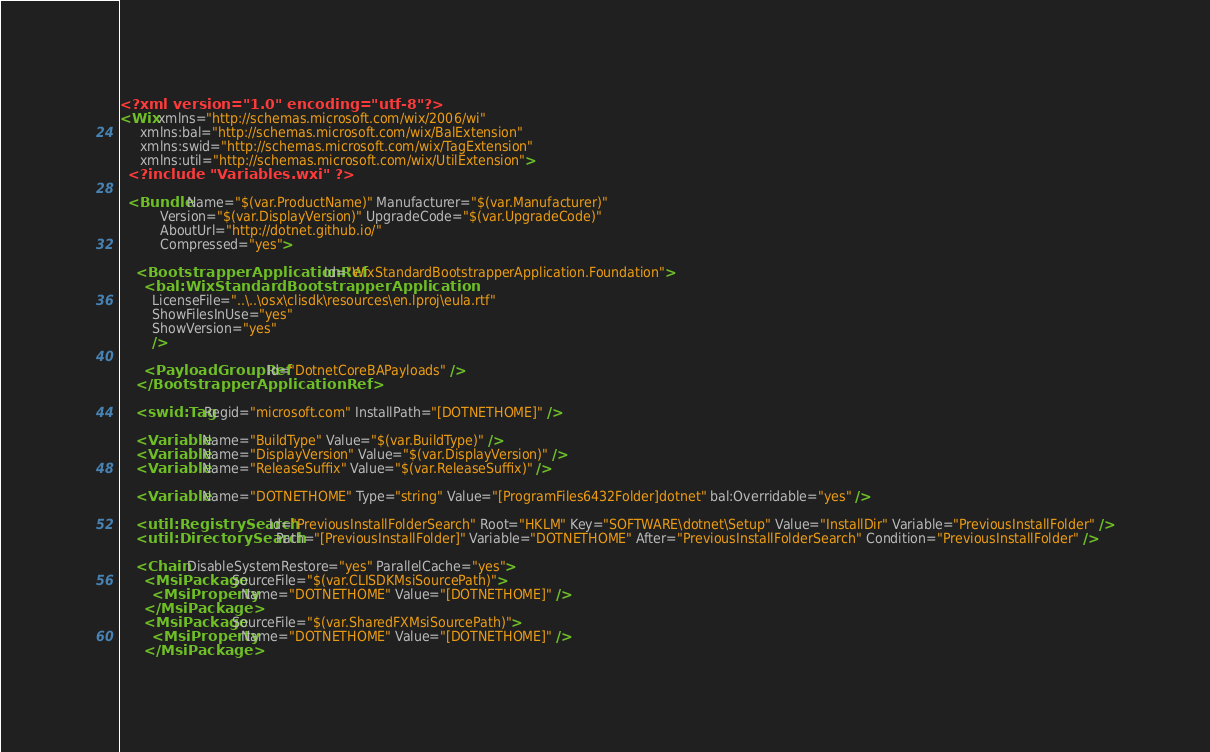Convert code to text. <code><loc_0><loc_0><loc_500><loc_500><_XML_><?xml version="1.0" encoding="utf-8"?>
<Wix xmlns="http://schemas.microsoft.com/wix/2006/wi"
     xmlns:bal="http://schemas.microsoft.com/wix/BalExtension"
     xmlns:swid="http://schemas.microsoft.com/wix/TagExtension"
     xmlns:util="http://schemas.microsoft.com/wix/UtilExtension">
  <?include "Variables.wxi" ?>

  <Bundle Name="$(var.ProductName)" Manufacturer="$(var.Manufacturer)"
          Version="$(var.DisplayVersion)" UpgradeCode="$(var.UpgradeCode)"
          AboutUrl="http://dotnet.github.io/"
          Compressed="yes">

    <BootstrapperApplicationRef Id="WixStandardBootstrapperApplication.Foundation">
      <bal:WixStandardBootstrapperApplication
        LicenseFile="..\..\osx\clisdk\resources\en.lproj\eula.rtf"
        ShowFilesInUse="yes"
        ShowVersion="yes"
        />

      <PayloadGroupRef Id="DotnetCoreBAPayloads" />
    </BootstrapperApplicationRef>

    <swid:Tag Regid="microsoft.com" InstallPath="[DOTNETHOME]" />

    <Variable Name="BuildType" Value="$(var.BuildType)" />
    <Variable Name="DisplayVersion" Value="$(var.DisplayVersion)" />
    <Variable Name="ReleaseSuffix" Value="$(var.ReleaseSuffix)" />

    <Variable Name="DOTNETHOME" Type="string" Value="[ProgramFiles6432Folder]dotnet" bal:Overridable="yes" />

    <util:RegistrySearch Id="PreviousInstallFolderSearch" Root="HKLM" Key="SOFTWARE\dotnet\Setup" Value="InstallDir" Variable="PreviousInstallFolder" />
    <util:DirectorySearch Path="[PreviousInstallFolder]" Variable="DOTNETHOME" After="PreviousInstallFolderSearch" Condition="PreviousInstallFolder" />

    <Chain DisableSystemRestore="yes" ParallelCache="yes">
      <MsiPackage SourceFile="$(var.CLISDKMsiSourcePath)">
        <MsiProperty Name="DOTNETHOME" Value="[DOTNETHOME]" />
      </MsiPackage>
      <MsiPackage SourceFile="$(var.SharedFXMsiSourcePath)">
        <MsiProperty Name="DOTNETHOME" Value="[DOTNETHOME]" />
      </MsiPackage></code> 